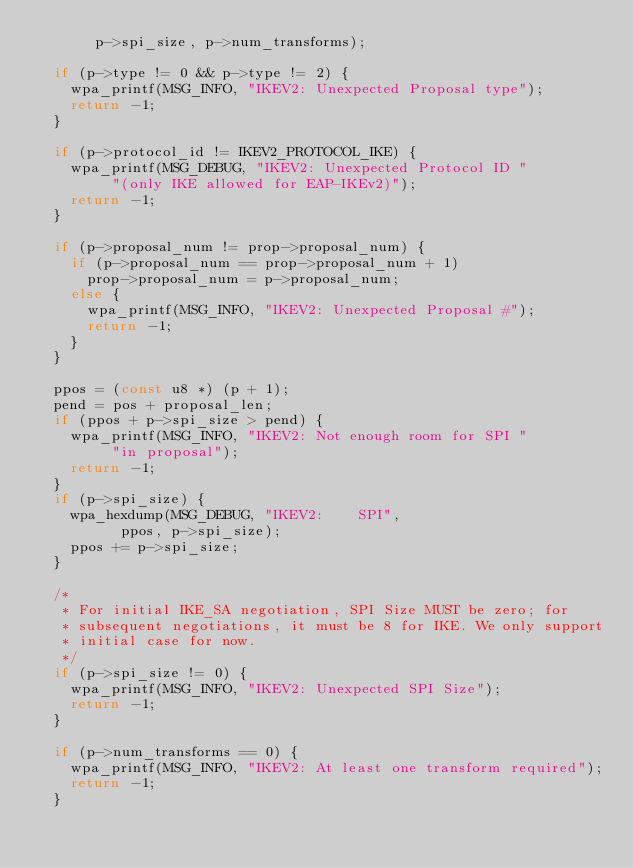Convert code to text. <code><loc_0><loc_0><loc_500><loc_500><_C_>		   p->spi_size, p->num_transforms);

	if (p->type != 0 && p->type != 2) {
		wpa_printf(MSG_INFO, "IKEV2: Unexpected Proposal type");
		return -1;
	}

	if (p->protocol_id != IKEV2_PROTOCOL_IKE) {
		wpa_printf(MSG_DEBUG, "IKEV2: Unexpected Protocol ID "
			   "(only IKE allowed for EAP-IKEv2)");
		return -1;
	}

	if (p->proposal_num != prop->proposal_num) {
		if (p->proposal_num == prop->proposal_num + 1)
			prop->proposal_num = p->proposal_num;
		else {
			wpa_printf(MSG_INFO, "IKEV2: Unexpected Proposal #");
			return -1;
		}
	}

	ppos = (const u8 *) (p + 1);
	pend = pos + proposal_len;
	if (ppos + p->spi_size > pend) {
		wpa_printf(MSG_INFO, "IKEV2: Not enough room for SPI "
			   "in proposal");
		return -1;
	}
	if (p->spi_size) {
		wpa_hexdump(MSG_DEBUG, "IKEV2:    SPI",
			    ppos, p->spi_size);
		ppos += p->spi_size;
	}

	/*
	 * For initial IKE_SA negotiation, SPI Size MUST be zero; for
	 * subsequent negotiations, it must be 8 for IKE. We only support
	 * initial case for now.
	 */
	if (p->spi_size != 0) {
		wpa_printf(MSG_INFO, "IKEV2: Unexpected SPI Size");
		return -1;
	}

	if (p->num_transforms == 0) {
		wpa_printf(MSG_INFO, "IKEV2: At least one transform required");
		return -1;
	}
</code> 